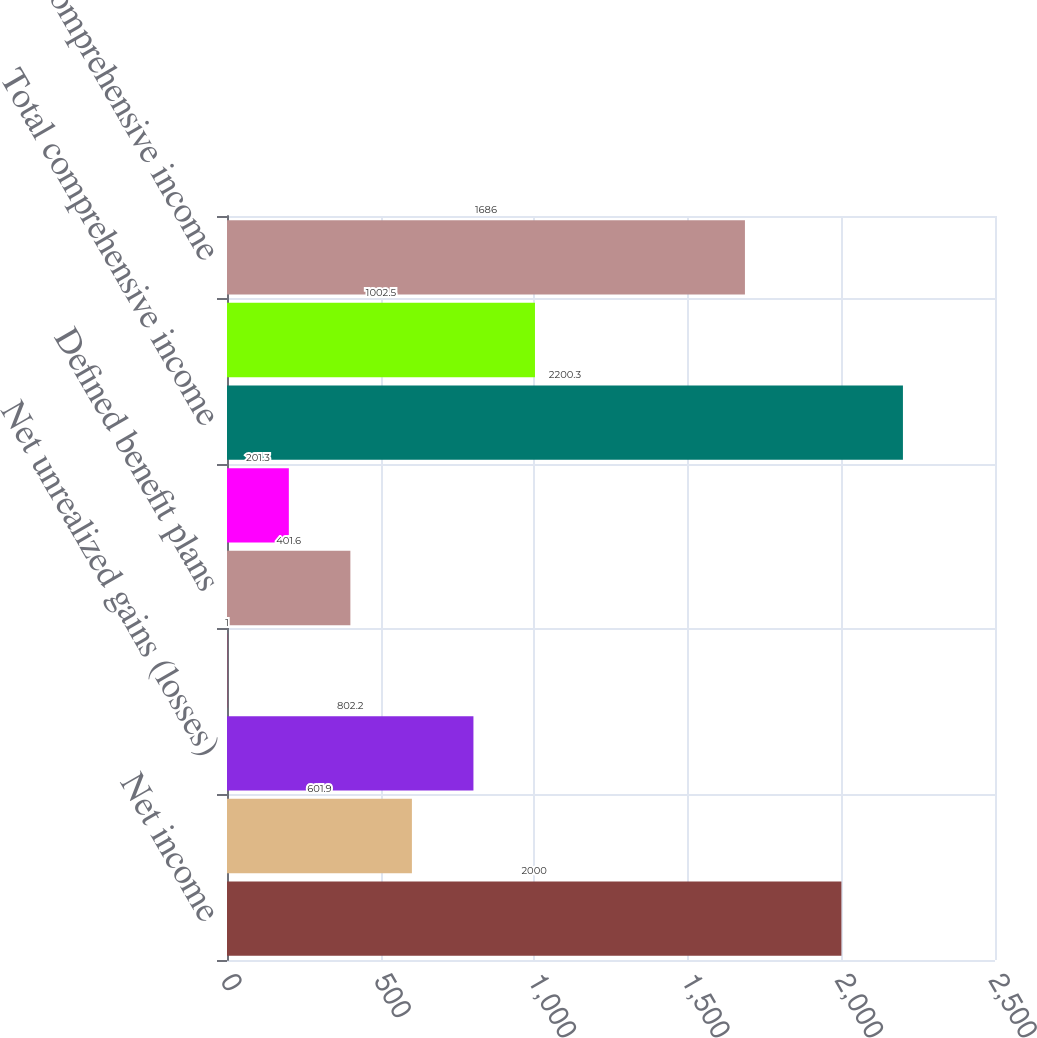Convert chart. <chart><loc_0><loc_0><loc_500><loc_500><bar_chart><fcel>Net income<fcel>Foreign currency translation<fcel>Net unrealized gains (losses)<fcel>Net unrealized gains on<fcel>Defined benefit plans<fcel>Total other comprehensive<fcel>Total comprehensive income<fcel>Less Comprehensive income<fcel>Comprehensive income<nl><fcel>2000<fcel>601.9<fcel>802.2<fcel>1<fcel>401.6<fcel>201.3<fcel>2200.3<fcel>1002.5<fcel>1686<nl></chart> 